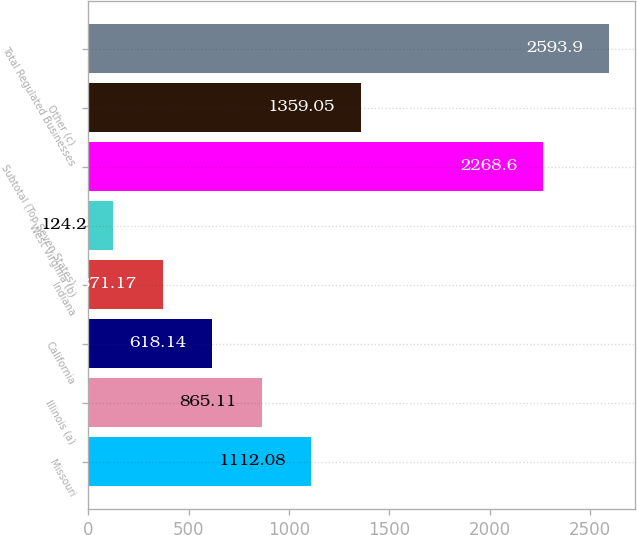Convert chart. <chart><loc_0><loc_0><loc_500><loc_500><bar_chart><fcel>Missouri<fcel>Illinois (a)<fcel>California<fcel>Indiana<fcel>West Virginia (b)<fcel>Subtotal (Top Seven States)<fcel>Other (c)<fcel>Total Regulated Businesses<nl><fcel>1112.08<fcel>865.11<fcel>618.14<fcel>371.17<fcel>124.2<fcel>2268.6<fcel>1359.05<fcel>2593.9<nl></chart> 